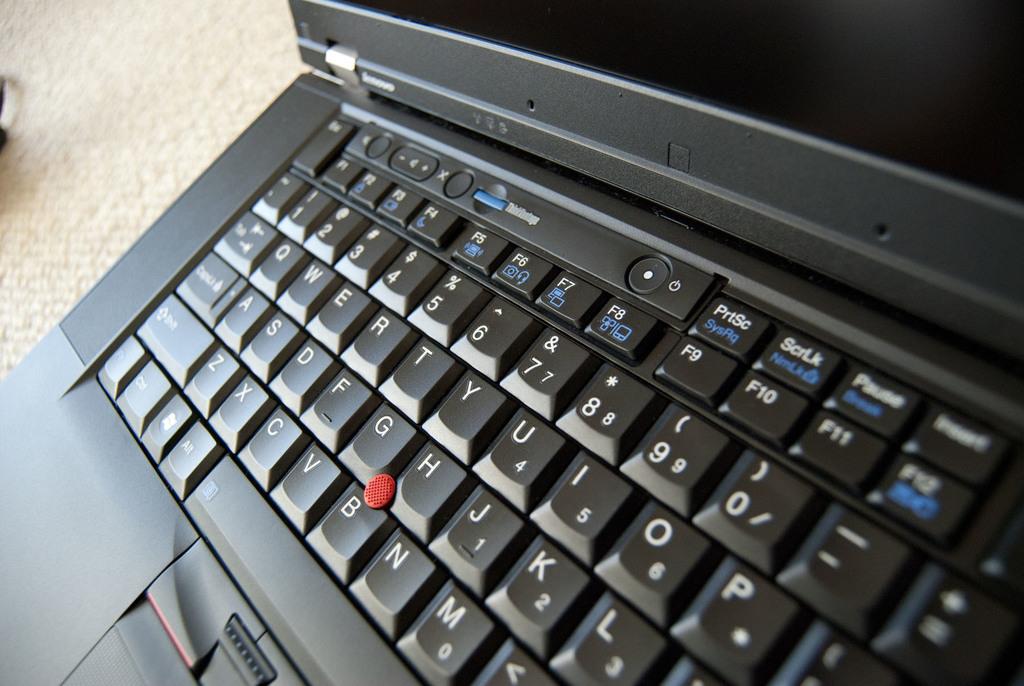Which key is located above f9?
Give a very brief answer. Prtsc. What is the top right key?
Offer a very short reply. Insert. 